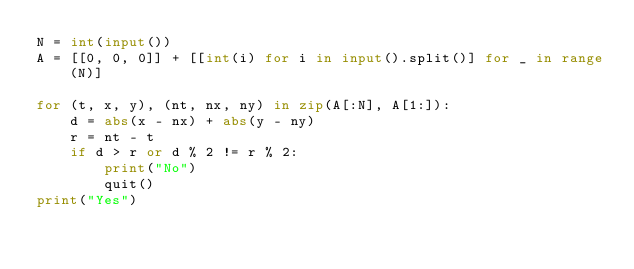<code> <loc_0><loc_0><loc_500><loc_500><_Python_>N = int(input())
A = [[0, 0, 0]] + [[int(i) for i in input().split()] for _ in range(N)]

for (t, x, y), (nt, nx, ny) in zip(A[:N], A[1:]):
    d = abs(x - nx) + abs(y - ny)
    r = nt - t
    if d > r or d % 2 != r % 2:
        print("No")
        quit()
print("Yes")</code> 